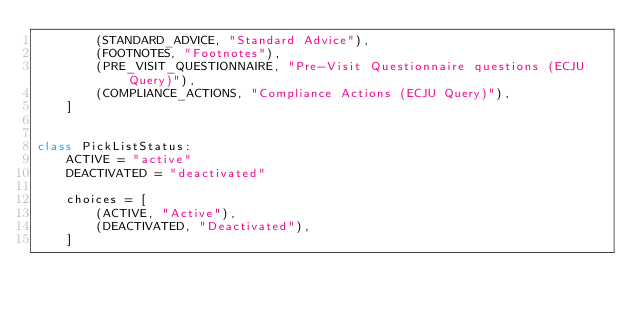<code> <loc_0><loc_0><loc_500><loc_500><_Python_>        (STANDARD_ADVICE, "Standard Advice"),
        (FOOTNOTES, "Footnotes"),
        (PRE_VISIT_QUESTIONNAIRE, "Pre-Visit Questionnaire questions (ECJU Query)"),
        (COMPLIANCE_ACTIONS, "Compliance Actions (ECJU Query)"),
    ]


class PickListStatus:
    ACTIVE = "active"
    DEACTIVATED = "deactivated"

    choices = [
        (ACTIVE, "Active"),
        (DEACTIVATED, "Deactivated"),
    ]
</code> 